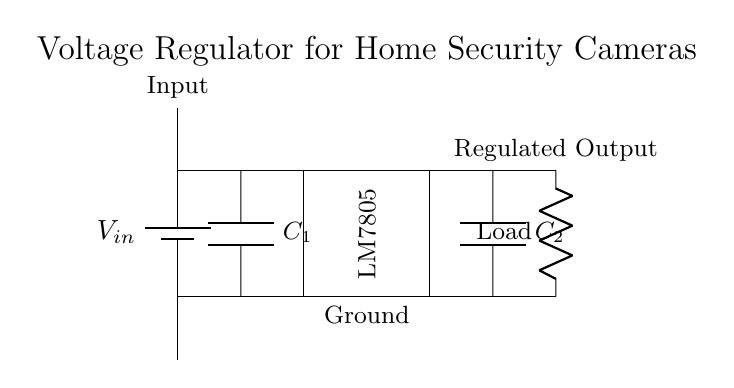What is the input voltage source in the circuit? The circuit diagram shows a battery labeled as Vin, which represents the input voltage source.
Answer: Vin What is the output voltage provided by the regulator? The LM7805 voltage regulator typically outputs a steady 5 volts, which is indicated in the function of this component in the circuit.
Answer: 5 volts What type of component is used as a regulator in this circuit? The circuit contains an LM7805, which is a linear voltage regulator.
Answer: LM7805 How many capacitors are present in the circuit? There are two capacitors labeled as C1 and C2, so a simple count confirms that there are two.
Answer: 2 What does the load represent in the circuit? The load in the circuit is represented by a resistor symbol and signifies the device that will consume the regulated output voltage.
Answer: Load Why are capacitors included in this circuit? Capacitors C1 and C2 are used for filtering and stabilizing the voltage, as they help in reducing voltage fluctuations that may affect the performance of the regulator and connected load.
Answer: Filtering and stability What does the ground symbol indicate in the circuit? The ground symbol indicates a reference point for the circuit, serving as a common return path for electric current, which is essential for the proper operation and safety of the circuit.
Answer: Reference point 